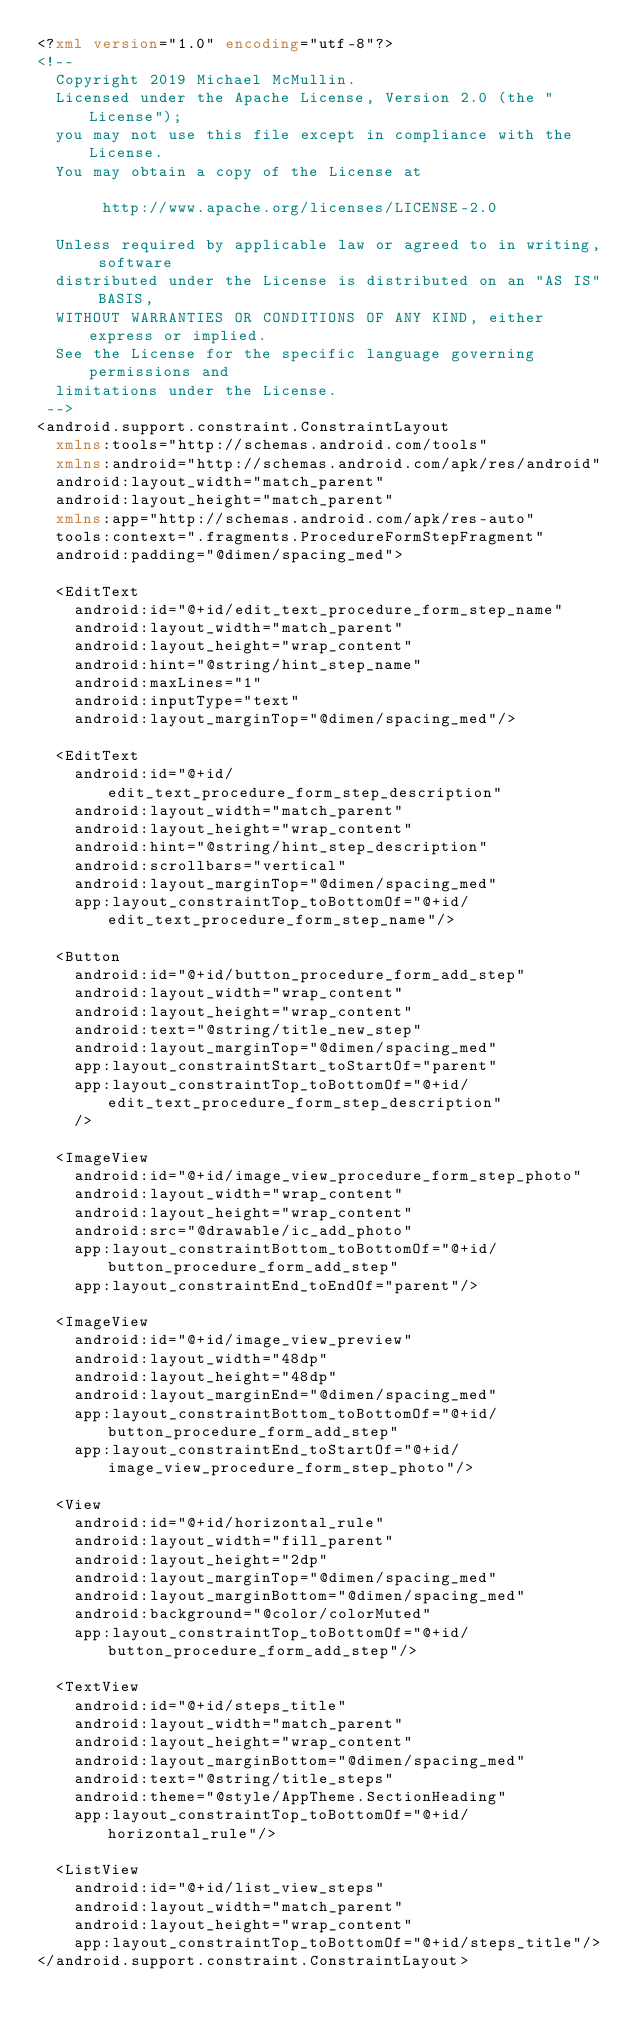<code> <loc_0><loc_0><loc_500><loc_500><_XML_><?xml version="1.0" encoding="utf-8"?>
<!--
	Copyright 2019 Michael McMullin.
	Licensed under the Apache License, Version 2.0 (the "License");
  you may not use this file except in compliance with the License.
  You may obtain a copy of the License at

       http://www.apache.org/licenses/LICENSE-2.0

  Unless required by applicable law or agreed to in writing, software
  distributed under the License is distributed on an "AS IS" BASIS,
  WITHOUT WARRANTIES OR CONDITIONS OF ANY KIND, either express or implied.
  See the License for the specific language governing permissions and
  limitations under the License.
 -->
<android.support.constraint.ConstraintLayout
  xmlns:tools="http://schemas.android.com/tools"
  xmlns:android="http://schemas.android.com/apk/res/android"
  android:layout_width="match_parent"
  android:layout_height="match_parent"
  xmlns:app="http://schemas.android.com/apk/res-auto"
  tools:context=".fragments.ProcedureFormStepFragment"
  android:padding="@dimen/spacing_med">

  <EditText
    android:id="@+id/edit_text_procedure_form_step_name"
    android:layout_width="match_parent"
    android:layout_height="wrap_content"
    android:hint="@string/hint_step_name"
    android:maxLines="1"
    android:inputType="text"
    android:layout_marginTop="@dimen/spacing_med"/>

  <EditText
    android:id="@+id/edit_text_procedure_form_step_description"
    android:layout_width="match_parent"
    android:layout_height="wrap_content"
    android:hint="@string/hint_step_description"
    android:scrollbars="vertical"
    android:layout_marginTop="@dimen/spacing_med"
    app:layout_constraintTop_toBottomOf="@+id/edit_text_procedure_form_step_name"/>

  <Button
    android:id="@+id/button_procedure_form_add_step"
    android:layout_width="wrap_content"
    android:layout_height="wrap_content"
    android:text="@string/title_new_step"
    android:layout_marginTop="@dimen/spacing_med"
    app:layout_constraintStart_toStartOf="parent"
    app:layout_constraintTop_toBottomOf="@+id/edit_text_procedure_form_step_description"
    />

  <ImageView
    android:id="@+id/image_view_procedure_form_step_photo"
    android:layout_width="wrap_content"
    android:layout_height="wrap_content"
    android:src="@drawable/ic_add_photo"
    app:layout_constraintBottom_toBottomOf="@+id/button_procedure_form_add_step"
    app:layout_constraintEnd_toEndOf="parent"/>

  <ImageView
    android:id="@+id/image_view_preview"
    android:layout_width="48dp"
    android:layout_height="48dp"
    android:layout_marginEnd="@dimen/spacing_med"
    app:layout_constraintBottom_toBottomOf="@+id/button_procedure_form_add_step"
    app:layout_constraintEnd_toStartOf="@+id/image_view_procedure_form_step_photo"/>

  <View
    android:id="@+id/horizontal_rule"
    android:layout_width="fill_parent"
    android:layout_height="2dp"
    android:layout_marginTop="@dimen/spacing_med"
    android:layout_marginBottom="@dimen/spacing_med"
    android:background="@color/colorMuted"
    app:layout_constraintTop_toBottomOf="@+id/button_procedure_form_add_step"/>

  <TextView
    android:id="@+id/steps_title"
    android:layout_width="match_parent"
    android:layout_height="wrap_content"
    android:layout_marginBottom="@dimen/spacing_med"
    android:text="@string/title_steps"
    android:theme="@style/AppTheme.SectionHeading"
    app:layout_constraintTop_toBottomOf="@+id/horizontal_rule"/>

  <ListView
    android:id="@+id/list_view_steps"
    android:layout_width="match_parent"
    android:layout_height="wrap_content"
    app:layout_constraintTop_toBottomOf="@+id/steps_title"/>
</android.support.constraint.ConstraintLayout></code> 